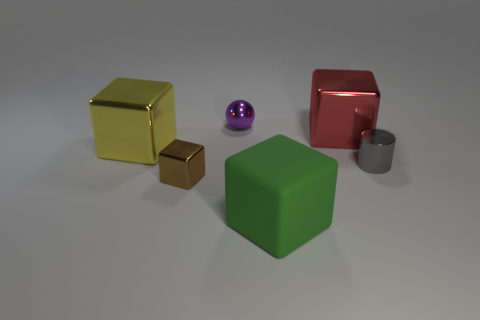Do the tiny thing that is right of the red cube and the tiny purple ball have the same material? Based on the image, the small brown cube to the right of the red cube and the tiny purple sphere seem to have different materials. The brown cube has a matte finish typical of objects mimicking wood or cardboard, whereas the purple sphere has a glossy surface that reflects light, indicating it could be made of a polished, maybe plastic material. 